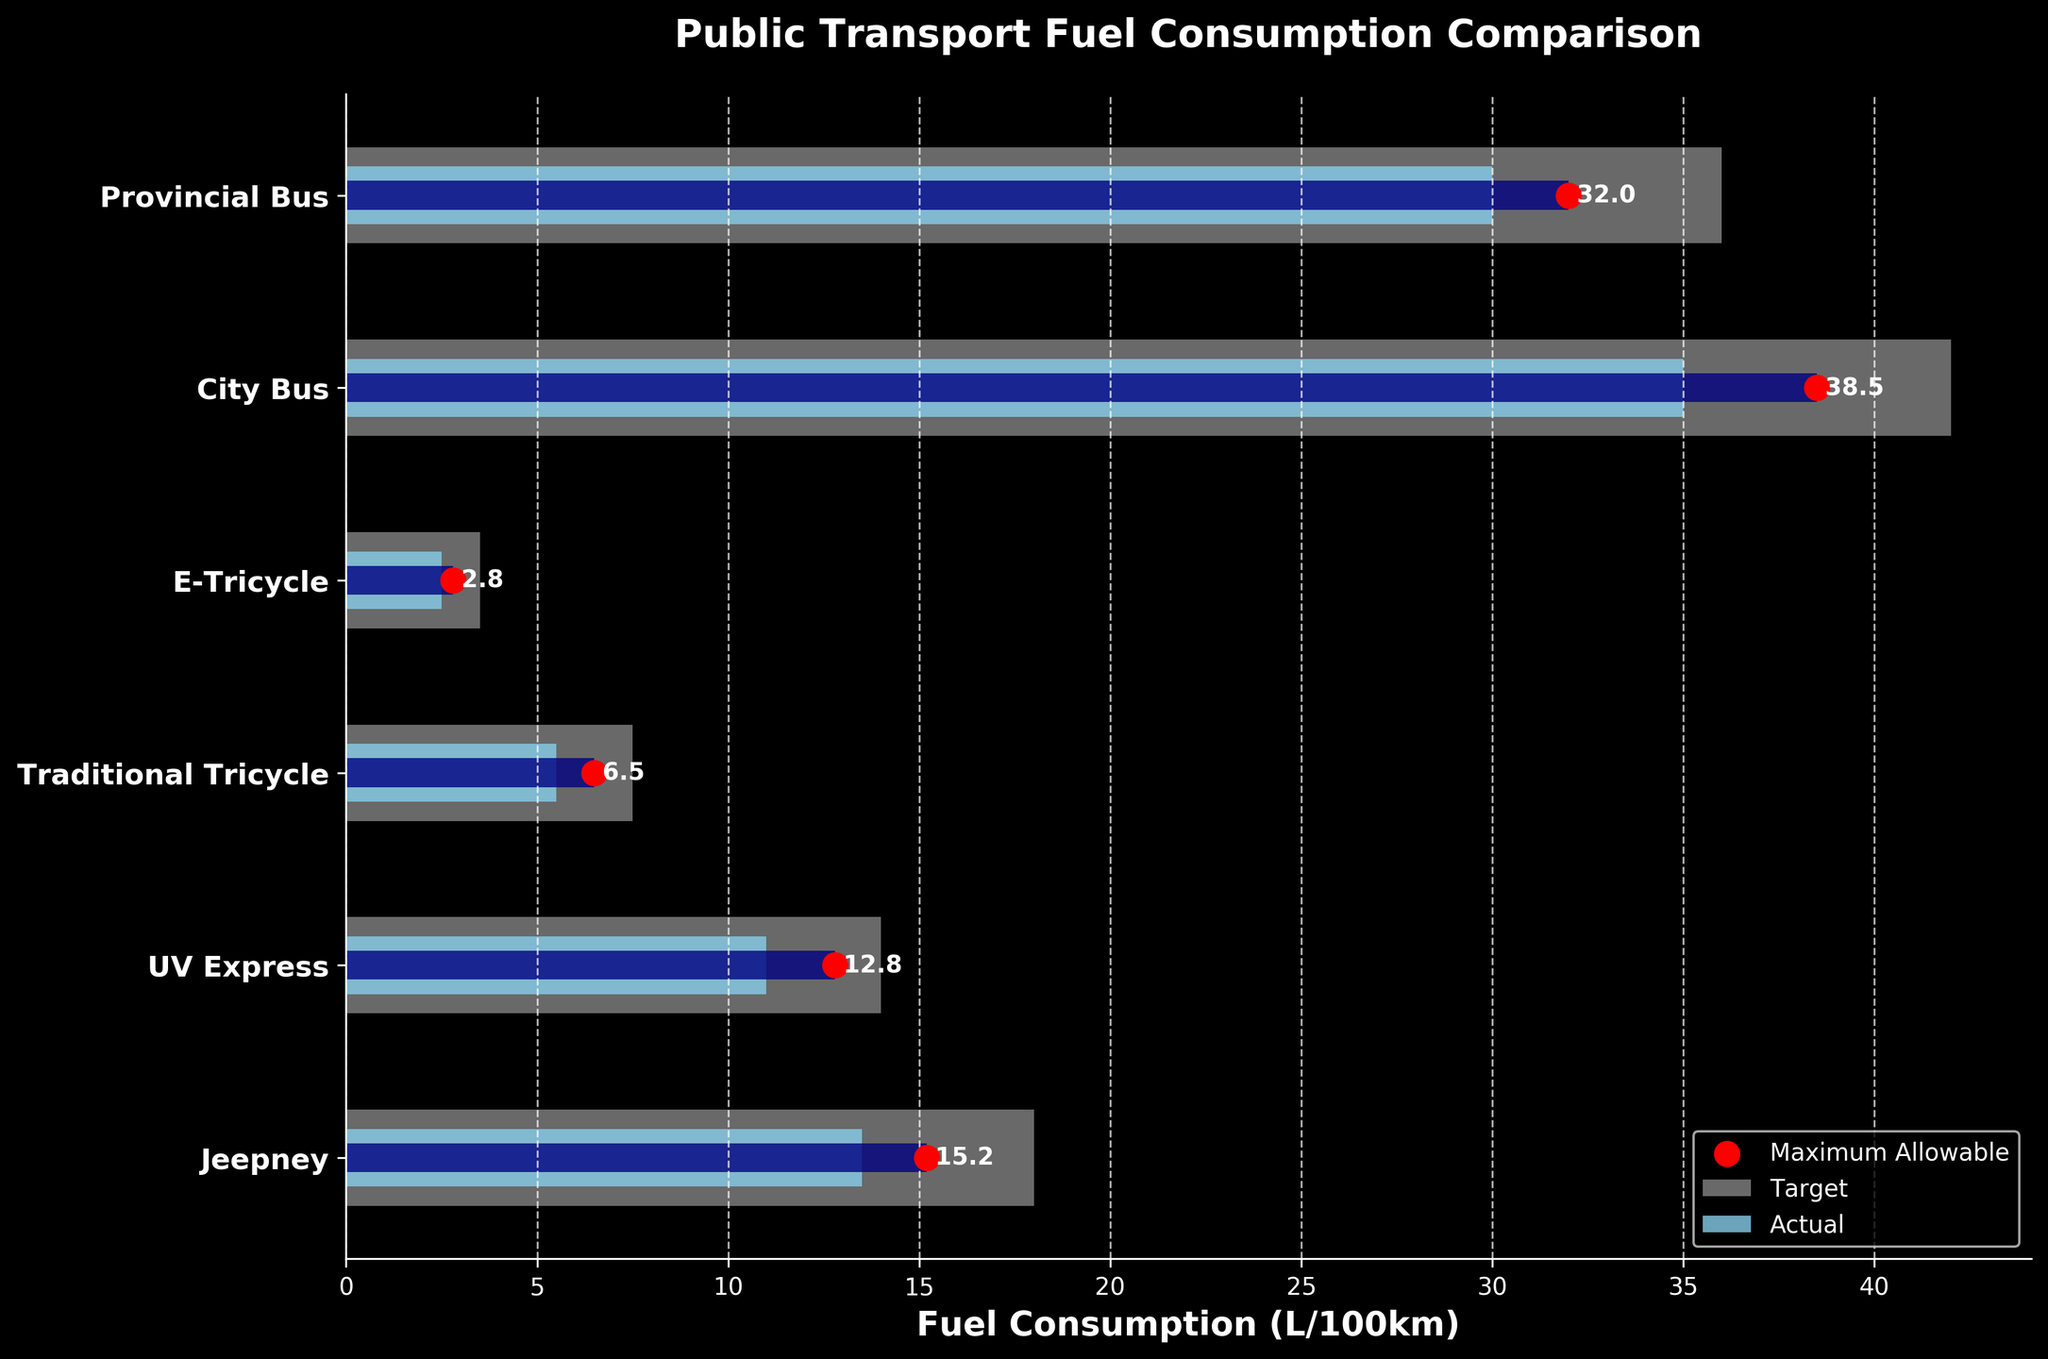What is the title of the plot? The title of the plot is usually found at the top center in larger and bold text. In this case, it reads "Public Transport Fuel Consumption Comparison."
Answer: Public Transport Fuel Consumption Comparison Which vehicle type has the highest actual fuel consumption? Look for the red markers indicating actual fuel consumption on the horizontal axis and check which one is highest. The City Bus has the marker farthest to the right.
Answer: City Bus How much higher is the Actual Consumption than the Target Consumption for the Jeepney? Find the bars corresponding to the Jeepney. The Actual Consumption is 15.2 L/100km and the Target Consumption is 13.5 L/100km. The difference is 15.2 - 13.5.
Answer: 1.7 L/100km Are there any vehicles that meet their Target Consumption? Compare the red markers (Actual Consumption) to the light blue bars (Target Consumption) for each vehicle type. None of the red markers are within their respective blue bars.
Answer: No What is the difference between the Maximum Allowable and Actual Consumption for the Provincial Bus? Look at the Provincial Bus data. The Maximum Allowable Consumption is 36 L/100km, and the Actual Consumption is 32 L/100km. The difference is 36 - 32.
Answer: 4 L/100km Which vehicle type has the smallest difference between Actual Consumption and Target Consumption? Calculate the difference for each vehicle type and find the smallest value. E-Tricycle: 2.8 - 2.5 = 0.3; Jeepney: 15.2 - 13.5 = 1.7; UV Express: 12.8 - 11.0 = 1.8; Tricycle: 6.5 - 5.5 = 1.0; City Bus: 38.5 - 35.0 = 3.5; Provincial Bus: 32 - 30 = 2. The E-Tricycle has the smallest difference of 0.3 L/100km.
Answer: E-Tricycle Which vehicle is performing the worst in terms of exceeding its Maximum Allowable Consumption? Compare the red markers to the maximum allowable bars for each vehicle to see which exceeds its bar the most. Calculate for each: Jeepney exceeds by 15.2 - 18 < 0 (does not exceed), UV Express: 12.8 - 14 < 0, Tricycle: 6.5 - 7.5 < 0, E-Tricycle: 2.8- 3.5 < 0, City Bus: 38.5 - 42 < 0, Provincial Bus: 32 - 36 < 0. None of the vehicles exceed the Maximum Allowable Consumption.
Answer: None Which two vehicle types have an Actual Consumption that is closer to each other than to any others? Compare the actual values to find the smallest difference between two values. Differences: City Bus - Provincial Bus = 38.5 - 32 = 6.5, Jeepney - UV Express = 15.2 - 12.8 = 2.4, Tricycle - E-Tricycle = 6.5 - 2.8 = 3.7. The closest values are Jeepney and UV Express.
Answer: Jeepney and UV Express Which vehicle type is closest to achieving its Target Consumption? Check the red markers versus the blue bars for each vehicle. The E-Tricycle ( with an Actual Consumption of 2.8 L/100km and a Target of 2.5 L/100km) is the closest to achieving its target.
Answer: E-Tricycle 